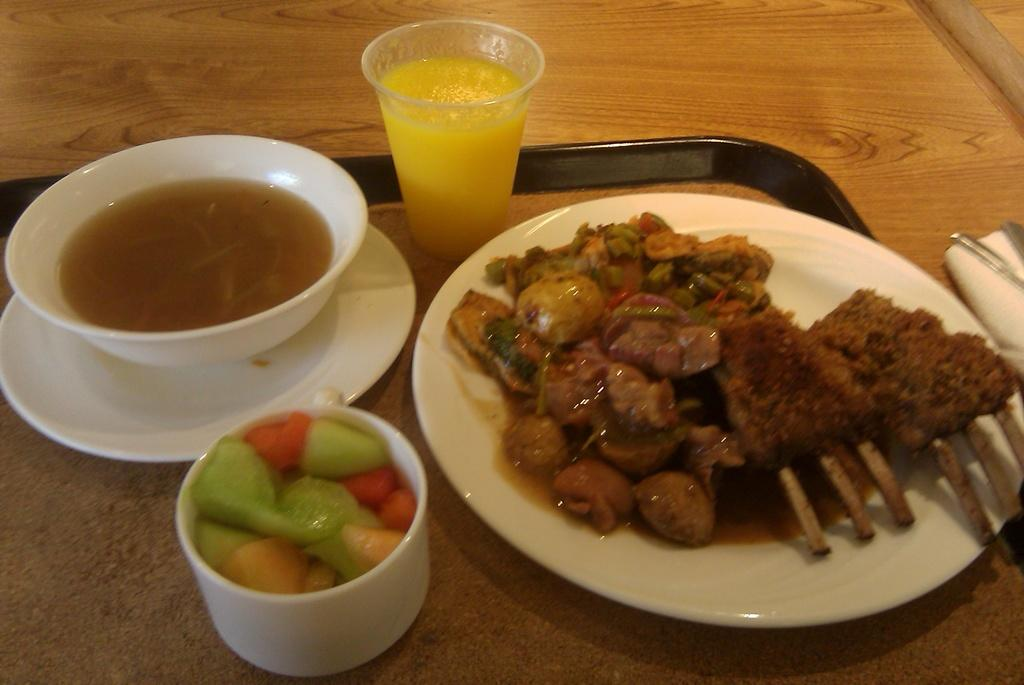What is the color of the plate that holds a food item in the image? The plate is white. What type of container holds another food item in the image? There is a food item in a cup. What is the material of the surface where a glass is placed? The surface is wooden. Where are these items located in the image? These items are in the middle of the image. Can you describe the fight between the butter and the act in the image? There is no fight, butter, or act present in the image. 